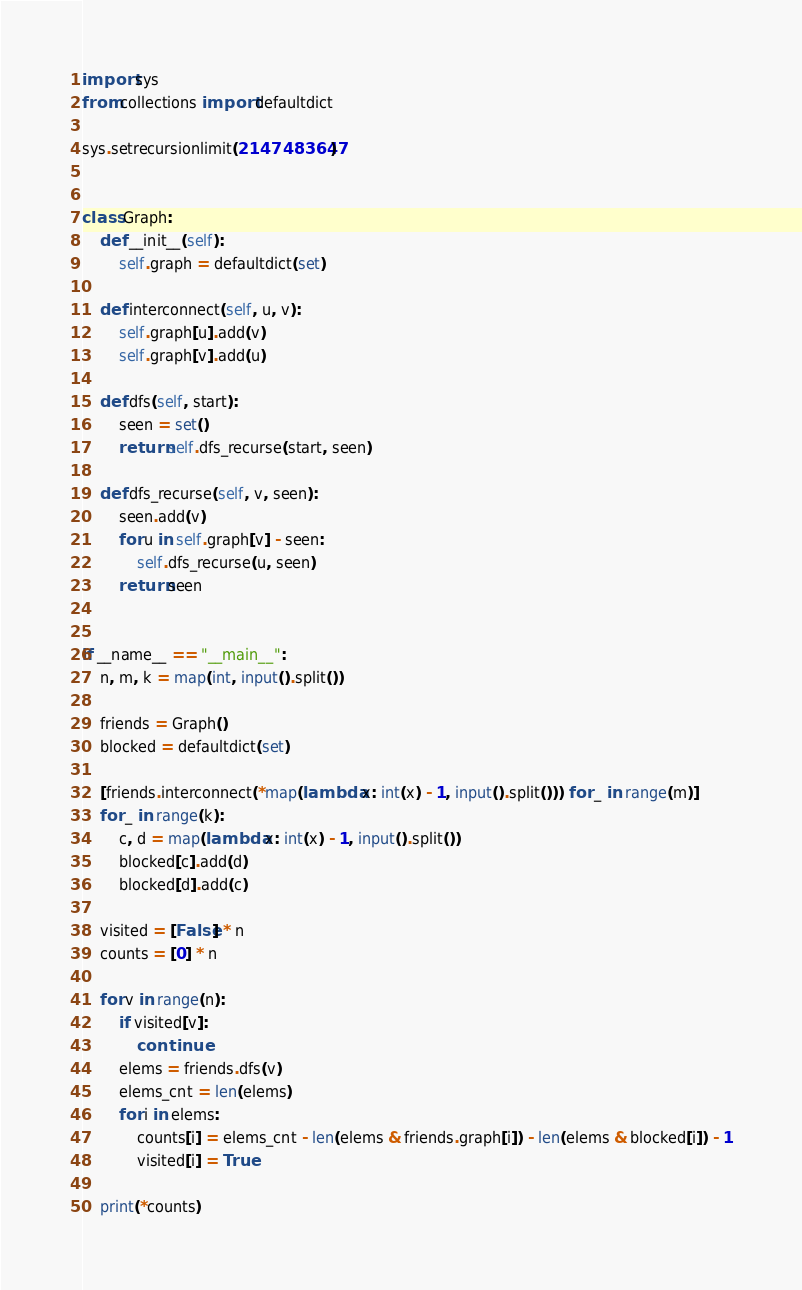Convert code to text. <code><loc_0><loc_0><loc_500><loc_500><_Python_>import sys
from collections import defaultdict

sys.setrecursionlimit(2147483647)


class Graph:
    def __init__(self):
        self.graph = defaultdict(set)

    def interconnect(self, u, v):
        self.graph[u].add(v)
        self.graph[v].add(u)

    def dfs(self, start):
        seen = set()
        return self.dfs_recurse(start, seen)

    def dfs_recurse(self, v, seen):
        seen.add(v)
        for u in self.graph[v] - seen:
            self.dfs_recurse(u, seen)
        return seen


if __name__ == "__main__":
    n, m, k = map(int, input().split())

    friends = Graph()
    blocked = defaultdict(set)

    [friends.interconnect(*map(lambda x: int(x) - 1, input().split())) for _ in range(m)]
    for _ in range(k):
        c, d = map(lambda x: int(x) - 1, input().split())
        blocked[c].add(d)
        blocked[d].add(c)

    visited = [False] * n
    counts = [0] * n

    for v in range(n):
        if visited[v]:
            continue
        elems = friends.dfs(v)
        elems_cnt = len(elems)
        for i in elems:
            counts[i] = elems_cnt - len(elems & friends.graph[i]) - len(elems & blocked[i]) - 1
            visited[i] = True

    print(*counts)
</code> 